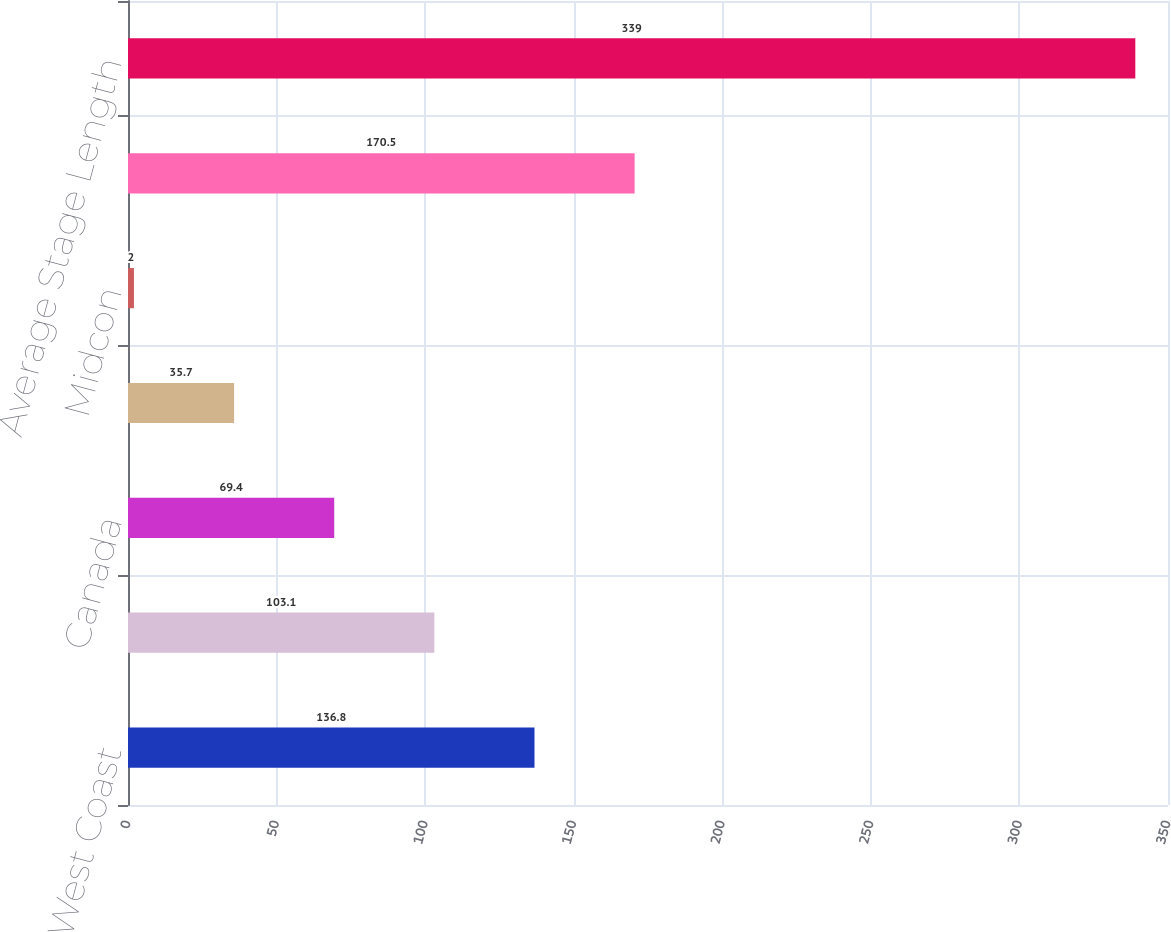Convert chart. <chart><loc_0><loc_0><loc_500><loc_500><bar_chart><fcel>West Coast<fcel>Pacific Northwest<fcel>Canada<fcel>Alaska<fcel>Midcon<fcel>Total<fcel>Average Stage Length<nl><fcel>136.8<fcel>103.1<fcel>69.4<fcel>35.7<fcel>2<fcel>170.5<fcel>339<nl></chart> 